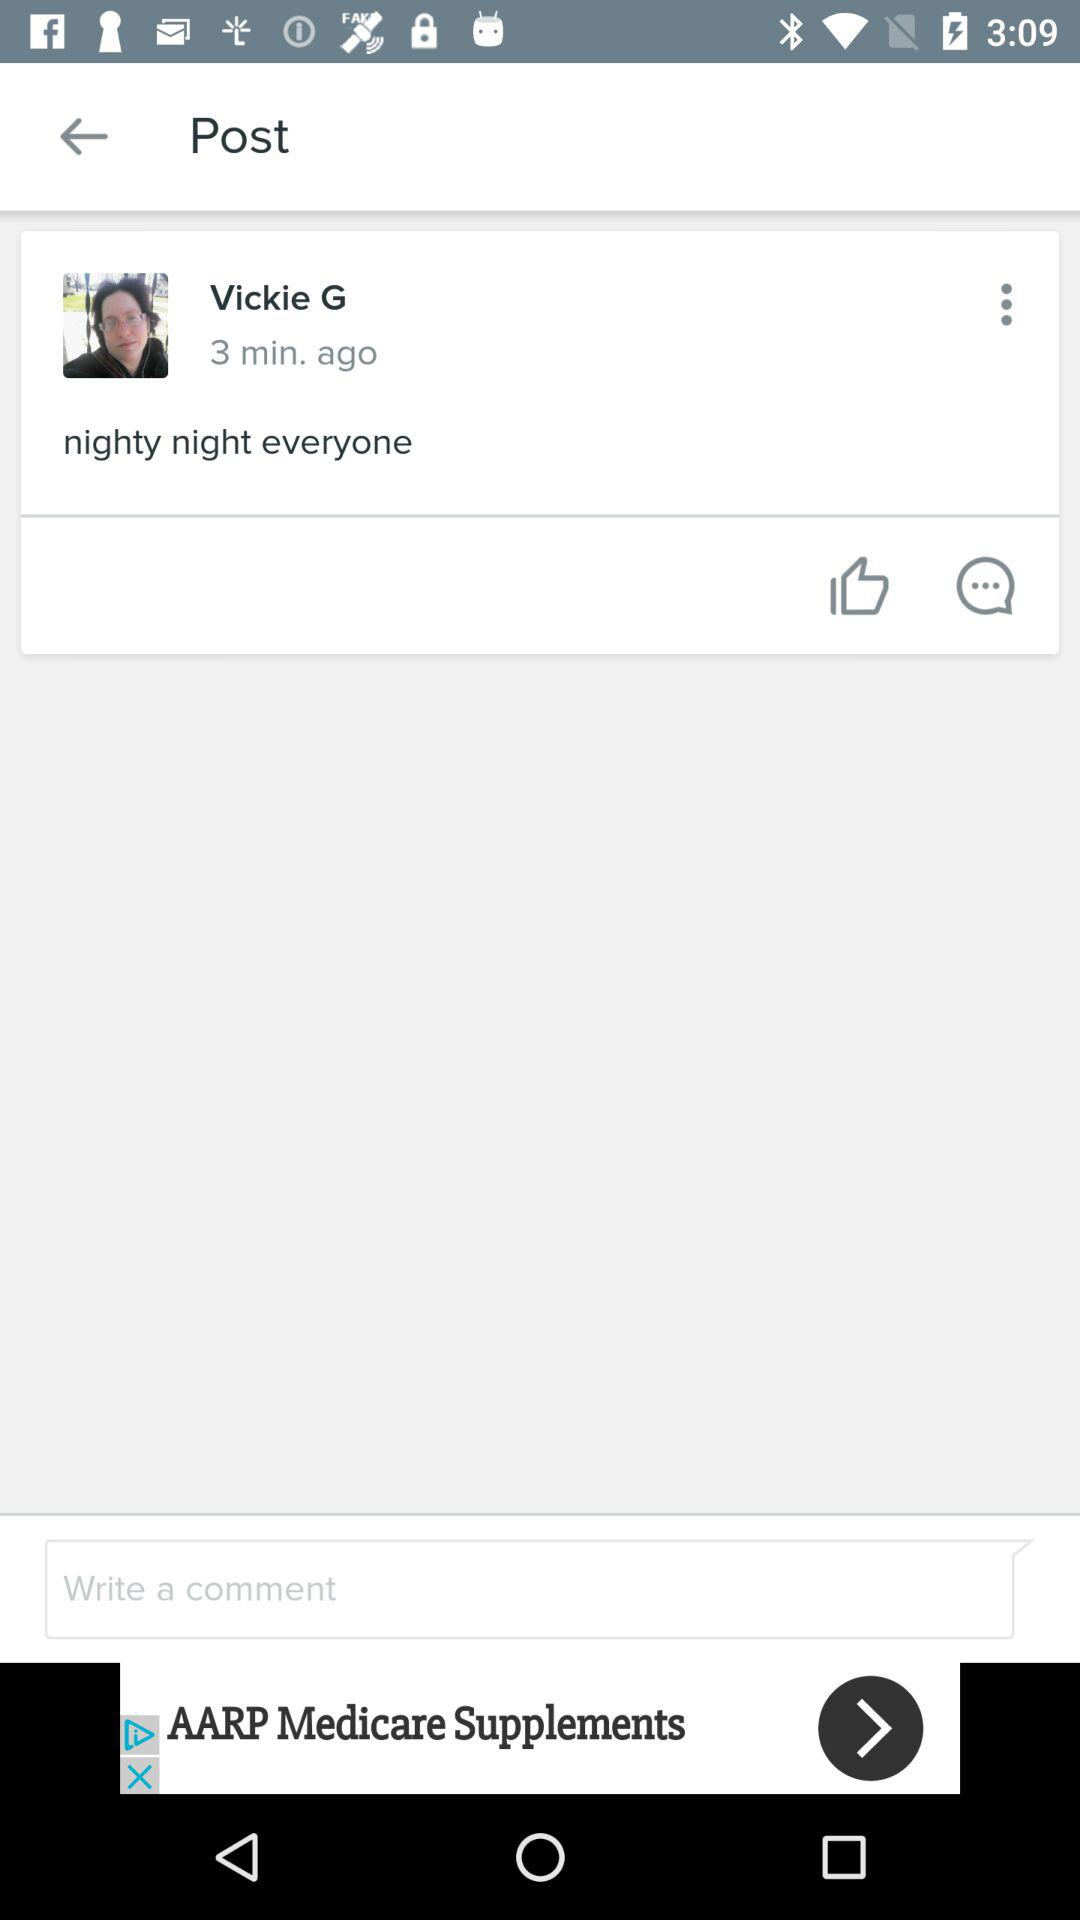How many minutes ago was the post posted? The post was posted 3 minutes ago. 